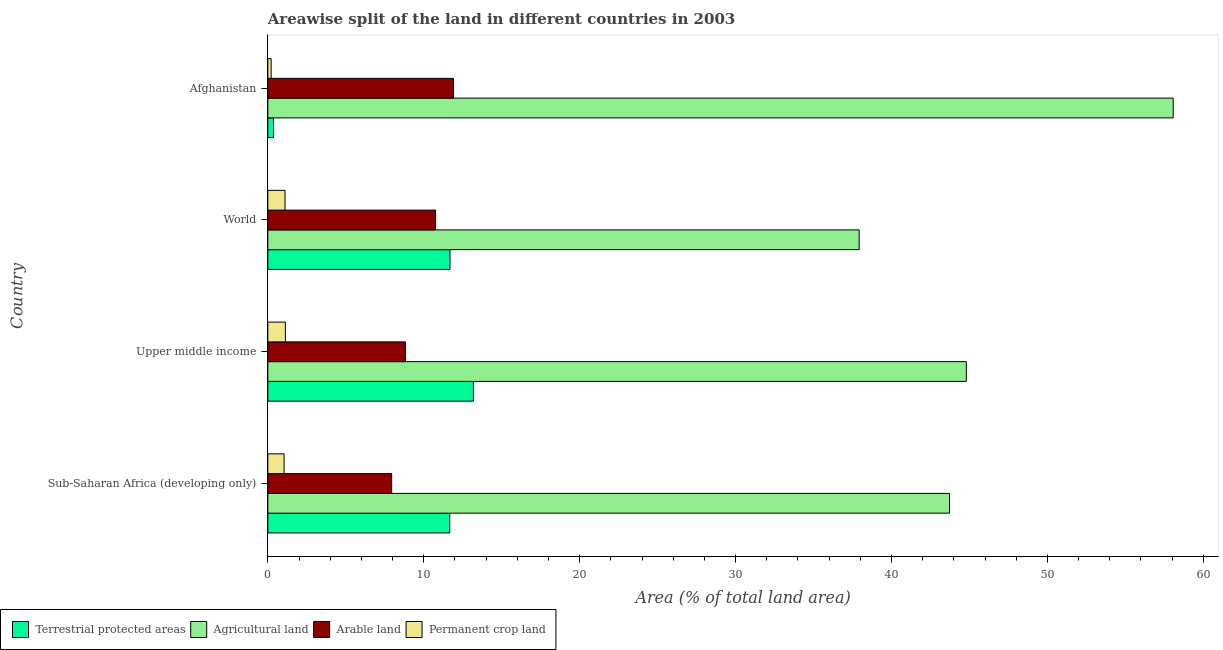Are the number of bars per tick equal to the number of legend labels?
Keep it short and to the point. Yes. Are the number of bars on each tick of the Y-axis equal?
Your response must be concise. Yes. How many bars are there on the 3rd tick from the top?
Your answer should be compact. 4. What is the label of the 1st group of bars from the top?
Offer a terse response. Afghanistan. In how many cases, is the number of bars for a given country not equal to the number of legend labels?
Make the answer very short. 0. What is the percentage of area under permanent crop land in Upper middle income?
Give a very brief answer. 1.13. Across all countries, what is the maximum percentage of area under arable land?
Offer a very short reply. 11.9. Across all countries, what is the minimum percentage of area under arable land?
Your answer should be very brief. 7.94. In which country was the percentage of area under agricultural land maximum?
Provide a succinct answer. Afghanistan. In which country was the percentage of area under permanent crop land minimum?
Ensure brevity in your answer.  Afghanistan. What is the total percentage of area under arable land in the graph?
Your answer should be compact. 39.43. What is the difference between the percentage of area under agricultural land in Upper middle income and that in World?
Keep it short and to the point. 6.87. What is the difference between the percentage of area under permanent crop land in World and the percentage of land under terrestrial protection in Upper middle income?
Your response must be concise. -12.08. What is the average percentage of land under terrestrial protection per country?
Make the answer very short. 9.22. What is the difference between the percentage of area under permanent crop land and percentage of area under arable land in Sub-Saharan Africa (developing only)?
Provide a short and direct response. -6.9. In how many countries, is the percentage of land under terrestrial protection greater than 48 %?
Make the answer very short. 0. What is the ratio of the percentage of area under arable land in Afghanistan to that in World?
Your answer should be very brief. 1.11. Is the difference between the percentage of area under agricultural land in Upper middle income and World greater than the difference between the percentage of area under arable land in Upper middle income and World?
Provide a succinct answer. Yes. What is the difference between the highest and the second highest percentage of area under permanent crop land?
Make the answer very short. 0.02. What is the difference between the highest and the lowest percentage of area under arable land?
Provide a succinct answer. 3.96. In how many countries, is the percentage of area under permanent crop land greater than the average percentage of area under permanent crop land taken over all countries?
Your response must be concise. 3. Is the sum of the percentage of area under permanent crop land in Afghanistan and World greater than the maximum percentage of area under agricultural land across all countries?
Ensure brevity in your answer.  No. What does the 3rd bar from the top in Upper middle income represents?
Give a very brief answer. Agricultural land. What does the 4th bar from the bottom in Sub-Saharan Africa (developing only) represents?
Keep it short and to the point. Permanent crop land. Are all the bars in the graph horizontal?
Your answer should be very brief. Yes. What is the difference between two consecutive major ticks on the X-axis?
Provide a succinct answer. 10. Where does the legend appear in the graph?
Give a very brief answer. Bottom left. How are the legend labels stacked?
Provide a short and direct response. Horizontal. What is the title of the graph?
Offer a very short reply. Areawise split of the land in different countries in 2003. Does "Other Minerals" appear as one of the legend labels in the graph?
Ensure brevity in your answer.  No. What is the label or title of the X-axis?
Your response must be concise. Area (% of total land area). What is the Area (% of total land area) in Terrestrial protected areas in Sub-Saharan Africa (developing only)?
Ensure brevity in your answer.  11.67. What is the Area (% of total land area) in Agricultural land in Sub-Saharan Africa (developing only)?
Your answer should be very brief. 43.72. What is the Area (% of total land area) in Arable land in Sub-Saharan Africa (developing only)?
Make the answer very short. 7.94. What is the Area (% of total land area) in Permanent crop land in Sub-Saharan Africa (developing only)?
Give a very brief answer. 1.04. What is the Area (% of total land area) in Terrestrial protected areas in Upper middle income?
Provide a short and direct response. 13.18. What is the Area (% of total land area) in Agricultural land in Upper middle income?
Ensure brevity in your answer.  44.8. What is the Area (% of total land area) in Arable land in Upper middle income?
Provide a succinct answer. 8.83. What is the Area (% of total land area) in Permanent crop land in Upper middle income?
Make the answer very short. 1.13. What is the Area (% of total land area) in Terrestrial protected areas in World?
Ensure brevity in your answer.  11.68. What is the Area (% of total land area) in Agricultural land in World?
Give a very brief answer. 37.93. What is the Area (% of total land area) of Arable land in World?
Keep it short and to the point. 10.76. What is the Area (% of total land area) in Permanent crop land in World?
Your answer should be very brief. 1.1. What is the Area (% of total land area) of Terrestrial protected areas in Afghanistan?
Keep it short and to the point. 0.37. What is the Area (% of total land area) in Agricultural land in Afghanistan?
Your answer should be very brief. 58.07. What is the Area (% of total land area) of Arable land in Afghanistan?
Provide a short and direct response. 11.9. What is the Area (% of total land area) in Permanent crop land in Afghanistan?
Your answer should be very brief. 0.21. Across all countries, what is the maximum Area (% of total land area) of Terrestrial protected areas?
Your response must be concise. 13.18. Across all countries, what is the maximum Area (% of total land area) of Agricultural land?
Make the answer very short. 58.07. Across all countries, what is the maximum Area (% of total land area) in Arable land?
Your answer should be very brief. 11.9. Across all countries, what is the maximum Area (% of total land area) in Permanent crop land?
Your answer should be compact. 1.13. Across all countries, what is the minimum Area (% of total land area) in Terrestrial protected areas?
Your answer should be compact. 0.37. Across all countries, what is the minimum Area (% of total land area) of Agricultural land?
Ensure brevity in your answer.  37.93. Across all countries, what is the minimum Area (% of total land area) in Arable land?
Make the answer very short. 7.94. Across all countries, what is the minimum Area (% of total land area) in Permanent crop land?
Your answer should be compact. 0.21. What is the total Area (% of total land area) in Terrestrial protected areas in the graph?
Ensure brevity in your answer.  36.9. What is the total Area (% of total land area) in Agricultural land in the graph?
Provide a short and direct response. 184.51. What is the total Area (% of total land area) in Arable land in the graph?
Ensure brevity in your answer.  39.43. What is the total Area (% of total land area) in Permanent crop land in the graph?
Provide a succinct answer. 3.48. What is the difference between the Area (% of total land area) of Terrestrial protected areas in Sub-Saharan Africa (developing only) and that in Upper middle income?
Your answer should be compact. -1.52. What is the difference between the Area (% of total land area) in Agricultural land in Sub-Saharan Africa (developing only) and that in Upper middle income?
Your response must be concise. -1.08. What is the difference between the Area (% of total land area) of Arable land in Sub-Saharan Africa (developing only) and that in Upper middle income?
Your response must be concise. -0.89. What is the difference between the Area (% of total land area) of Permanent crop land in Sub-Saharan Africa (developing only) and that in Upper middle income?
Your answer should be very brief. -0.08. What is the difference between the Area (% of total land area) in Terrestrial protected areas in Sub-Saharan Africa (developing only) and that in World?
Offer a very short reply. -0.02. What is the difference between the Area (% of total land area) in Agricultural land in Sub-Saharan Africa (developing only) and that in World?
Provide a short and direct response. 5.8. What is the difference between the Area (% of total land area) in Arable land in Sub-Saharan Africa (developing only) and that in World?
Offer a very short reply. -2.82. What is the difference between the Area (% of total land area) in Permanent crop land in Sub-Saharan Africa (developing only) and that in World?
Offer a terse response. -0.06. What is the difference between the Area (% of total land area) of Terrestrial protected areas in Sub-Saharan Africa (developing only) and that in Afghanistan?
Your answer should be very brief. 11.3. What is the difference between the Area (% of total land area) in Agricultural land in Sub-Saharan Africa (developing only) and that in Afghanistan?
Offer a very short reply. -14.35. What is the difference between the Area (% of total land area) in Arable land in Sub-Saharan Africa (developing only) and that in Afghanistan?
Your response must be concise. -3.96. What is the difference between the Area (% of total land area) of Permanent crop land in Sub-Saharan Africa (developing only) and that in Afghanistan?
Keep it short and to the point. 0.83. What is the difference between the Area (% of total land area) in Terrestrial protected areas in Upper middle income and that in World?
Your response must be concise. 1.5. What is the difference between the Area (% of total land area) of Agricultural land in Upper middle income and that in World?
Your answer should be compact. 6.87. What is the difference between the Area (% of total land area) in Arable land in Upper middle income and that in World?
Your response must be concise. -1.93. What is the difference between the Area (% of total land area) of Permanent crop land in Upper middle income and that in World?
Your answer should be very brief. 0.02. What is the difference between the Area (% of total land area) in Terrestrial protected areas in Upper middle income and that in Afghanistan?
Give a very brief answer. 12.82. What is the difference between the Area (% of total land area) in Agricultural land in Upper middle income and that in Afghanistan?
Your answer should be compact. -13.27. What is the difference between the Area (% of total land area) of Arable land in Upper middle income and that in Afghanistan?
Offer a very short reply. -3.08. What is the difference between the Area (% of total land area) of Permanent crop land in Upper middle income and that in Afghanistan?
Make the answer very short. 0.91. What is the difference between the Area (% of total land area) in Terrestrial protected areas in World and that in Afghanistan?
Provide a succinct answer. 11.32. What is the difference between the Area (% of total land area) in Agricultural land in World and that in Afghanistan?
Make the answer very short. -20.14. What is the difference between the Area (% of total land area) in Arable land in World and that in Afghanistan?
Provide a short and direct response. -1.15. What is the difference between the Area (% of total land area) in Permanent crop land in World and that in Afghanistan?
Your answer should be compact. 0.89. What is the difference between the Area (% of total land area) in Terrestrial protected areas in Sub-Saharan Africa (developing only) and the Area (% of total land area) in Agricultural land in Upper middle income?
Your response must be concise. -33.13. What is the difference between the Area (% of total land area) in Terrestrial protected areas in Sub-Saharan Africa (developing only) and the Area (% of total land area) in Arable land in Upper middle income?
Your response must be concise. 2.84. What is the difference between the Area (% of total land area) in Terrestrial protected areas in Sub-Saharan Africa (developing only) and the Area (% of total land area) in Permanent crop land in Upper middle income?
Your response must be concise. 10.54. What is the difference between the Area (% of total land area) of Agricultural land in Sub-Saharan Africa (developing only) and the Area (% of total land area) of Arable land in Upper middle income?
Offer a terse response. 34.89. What is the difference between the Area (% of total land area) in Agricultural land in Sub-Saharan Africa (developing only) and the Area (% of total land area) in Permanent crop land in Upper middle income?
Your response must be concise. 42.6. What is the difference between the Area (% of total land area) in Arable land in Sub-Saharan Africa (developing only) and the Area (% of total land area) in Permanent crop land in Upper middle income?
Provide a short and direct response. 6.81. What is the difference between the Area (% of total land area) in Terrestrial protected areas in Sub-Saharan Africa (developing only) and the Area (% of total land area) in Agricultural land in World?
Ensure brevity in your answer.  -26.26. What is the difference between the Area (% of total land area) of Terrestrial protected areas in Sub-Saharan Africa (developing only) and the Area (% of total land area) of Arable land in World?
Your response must be concise. 0.91. What is the difference between the Area (% of total land area) of Terrestrial protected areas in Sub-Saharan Africa (developing only) and the Area (% of total land area) of Permanent crop land in World?
Your answer should be very brief. 10.56. What is the difference between the Area (% of total land area) of Agricultural land in Sub-Saharan Africa (developing only) and the Area (% of total land area) of Arable land in World?
Offer a terse response. 32.97. What is the difference between the Area (% of total land area) in Agricultural land in Sub-Saharan Africa (developing only) and the Area (% of total land area) in Permanent crop land in World?
Your response must be concise. 42.62. What is the difference between the Area (% of total land area) in Arable land in Sub-Saharan Africa (developing only) and the Area (% of total land area) in Permanent crop land in World?
Your answer should be very brief. 6.84. What is the difference between the Area (% of total land area) of Terrestrial protected areas in Sub-Saharan Africa (developing only) and the Area (% of total land area) of Agricultural land in Afghanistan?
Your response must be concise. -46.4. What is the difference between the Area (% of total land area) in Terrestrial protected areas in Sub-Saharan Africa (developing only) and the Area (% of total land area) in Arable land in Afghanistan?
Offer a terse response. -0.24. What is the difference between the Area (% of total land area) in Terrestrial protected areas in Sub-Saharan Africa (developing only) and the Area (% of total land area) in Permanent crop land in Afghanistan?
Ensure brevity in your answer.  11.46. What is the difference between the Area (% of total land area) of Agricultural land in Sub-Saharan Africa (developing only) and the Area (% of total land area) of Arable land in Afghanistan?
Provide a short and direct response. 31.82. What is the difference between the Area (% of total land area) of Agricultural land in Sub-Saharan Africa (developing only) and the Area (% of total land area) of Permanent crop land in Afghanistan?
Your response must be concise. 43.51. What is the difference between the Area (% of total land area) of Arable land in Sub-Saharan Africa (developing only) and the Area (% of total land area) of Permanent crop land in Afghanistan?
Provide a short and direct response. 7.73. What is the difference between the Area (% of total land area) in Terrestrial protected areas in Upper middle income and the Area (% of total land area) in Agricultural land in World?
Provide a short and direct response. -24.74. What is the difference between the Area (% of total land area) of Terrestrial protected areas in Upper middle income and the Area (% of total land area) of Arable land in World?
Give a very brief answer. 2.43. What is the difference between the Area (% of total land area) of Terrestrial protected areas in Upper middle income and the Area (% of total land area) of Permanent crop land in World?
Provide a short and direct response. 12.08. What is the difference between the Area (% of total land area) of Agricultural land in Upper middle income and the Area (% of total land area) of Arable land in World?
Your answer should be compact. 34.04. What is the difference between the Area (% of total land area) of Agricultural land in Upper middle income and the Area (% of total land area) of Permanent crop land in World?
Your answer should be very brief. 43.69. What is the difference between the Area (% of total land area) in Arable land in Upper middle income and the Area (% of total land area) in Permanent crop land in World?
Provide a short and direct response. 7.73. What is the difference between the Area (% of total land area) of Terrestrial protected areas in Upper middle income and the Area (% of total land area) of Agricultural land in Afghanistan?
Your answer should be compact. -44.88. What is the difference between the Area (% of total land area) in Terrestrial protected areas in Upper middle income and the Area (% of total land area) in Arable land in Afghanistan?
Offer a very short reply. 1.28. What is the difference between the Area (% of total land area) of Terrestrial protected areas in Upper middle income and the Area (% of total land area) of Permanent crop land in Afghanistan?
Your answer should be very brief. 12.97. What is the difference between the Area (% of total land area) in Agricultural land in Upper middle income and the Area (% of total land area) in Arable land in Afghanistan?
Your answer should be very brief. 32.89. What is the difference between the Area (% of total land area) in Agricultural land in Upper middle income and the Area (% of total land area) in Permanent crop land in Afghanistan?
Offer a very short reply. 44.59. What is the difference between the Area (% of total land area) of Arable land in Upper middle income and the Area (% of total land area) of Permanent crop land in Afghanistan?
Give a very brief answer. 8.62. What is the difference between the Area (% of total land area) in Terrestrial protected areas in World and the Area (% of total land area) in Agricultural land in Afghanistan?
Ensure brevity in your answer.  -46.38. What is the difference between the Area (% of total land area) in Terrestrial protected areas in World and the Area (% of total land area) in Arable land in Afghanistan?
Offer a very short reply. -0.22. What is the difference between the Area (% of total land area) of Terrestrial protected areas in World and the Area (% of total land area) of Permanent crop land in Afghanistan?
Your answer should be very brief. 11.47. What is the difference between the Area (% of total land area) of Agricultural land in World and the Area (% of total land area) of Arable land in Afghanistan?
Your answer should be very brief. 26.02. What is the difference between the Area (% of total land area) in Agricultural land in World and the Area (% of total land area) in Permanent crop land in Afghanistan?
Offer a terse response. 37.71. What is the difference between the Area (% of total land area) of Arable land in World and the Area (% of total land area) of Permanent crop land in Afghanistan?
Give a very brief answer. 10.54. What is the average Area (% of total land area) of Terrestrial protected areas per country?
Provide a short and direct response. 9.23. What is the average Area (% of total land area) in Agricultural land per country?
Offer a terse response. 46.13. What is the average Area (% of total land area) in Arable land per country?
Ensure brevity in your answer.  9.86. What is the average Area (% of total land area) of Permanent crop land per country?
Offer a terse response. 0.87. What is the difference between the Area (% of total land area) in Terrestrial protected areas and Area (% of total land area) in Agricultural land in Sub-Saharan Africa (developing only)?
Offer a very short reply. -32.05. What is the difference between the Area (% of total land area) in Terrestrial protected areas and Area (% of total land area) in Arable land in Sub-Saharan Africa (developing only)?
Give a very brief answer. 3.73. What is the difference between the Area (% of total land area) of Terrestrial protected areas and Area (% of total land area) of Permanent crop land in Sub-Saharan Africa (developing only)?
Provide a succinct answer. 10.63. What is the difference between the Area (% of total land area) in Agricultural land and Area (% of total land area) in Arable land in Sub-Saharan Africa (developing only)?
Your answer should be compact. 35.78. What is the difference between the Area (% of total land area) in Agricultural land and Area (% of total land area) in Permanent crop land in Sub-Saharan Africa (developing only)?
Offer a very short reply. 42.68. What is the difference between the Area (% of total land area) of Arable land and Area (% of total land area) of Permanent crop land in Sub-Saharan Africa (developing only)?
Give a very brief answer. 6.9. What is the difference between the Area (% of total land area) in Terrestrial protected areas and Area (% of total land area) in Agricultural land in Upper middle income?
Offer a terse response. -31.61. What is the difference between the Area (% of total land area) in Terrestrial protected areas and Area (% of total land area) in Arable land in Upper middle income?
Give a very brief answer. 4.36. What is the difference between the Area (% of total land area) of Terrestrial protected areas and Area (% of total land area) of Permanent crop land in Upper middle income?
Make the answer very short. 12.06. What is the difference between the Area (% of total land area) of Agricultural land and Area (% of total land area) of Arable land in Upper middle income?
Provide a short and direct response. 35.97. What is the difference between the Area (% of total land area) of Agricultural land and Area (% of total land area) of Permanent crop land in Upper middle income?
Your answer should be compact. 43.67. What is the difference between the Area (% of total land area) in Arable land and Area (% of total land area) in Permanent crop land in Upper middle income?
Ensure brevity in your answer.  7.7. What is the difference between the Area (% of total land area) in Terrestrial protected areas and Area (% of total land area) in Agricultural land in World?
Your answer should be very brief. -26.24. What is the difference between the Area (% of total land area) in Terrestrial protected areas and Area (% of total land area) in Arable land in World?
Offer a very short reply. 0.93. What is the difference between the Area (% of total land area) of Terrestrial protected areas and Area (% of total land area) of Permanent crop land in World?
Provide a succinct answer. 10.58. What is the difference between the Area (% of total land area) in Agricultural land and Area (% of total land area) in Arable land in World?
Keep it short and to the point. 27.17. What is the difference between the Area (% of total land area) in Agricultural land and Area (% of total land area) in Permanent crop land in World?
Offer a terse response. 36.82. What is the difference between the Area (% of total land area) of Arable land and Area (% of total land area) of Permanent crop land in World?
Offer a terse response. 9.65. What is the difference between the Area (% of total land area) in Terrestrial protected areas and Area (% of total land area) in Agricultural land in Afghanistan?
Your answer should be compact. -57.7. What is the difference between the Area (% of total land area) of Terrestrial protected areas and Area (% of total land area) of Arable land in Afghanistan?
Your answer should be very brief. -11.54. What is the difference between the Area (% of total land area) of Terrestrial protected areas and Area (% of total land area) of Permanent crop land in Afghanistan?
Your response must be concise. 0.16. What is the difference between the Area (% of total land area) of Agricultural land and Area (% of total land area) of Arable land in Afghanistan?
Give a very brief answer. 46.16. What is the difference between the Area (% of total land area) of Agricultural land and Area (% of total land area) of Permanent crop land in Afghanistan?
Keep it short and to the point. 57.86. What is the difference between the Area (% of total land area) of Arable land and Area (% of total land area) of Permanent crop land in Afghanistan?
Give a very brief answer. 11.69. What is the ratio of the Area (% of total land area) in Terrestrial protected areas in Sub-Saharan Africa (developing only) to that in Upper middle income?
Your answer should be very brief. 0.88. What is the ratio of the Area (% of total land area) in Agricultural land in Sub-Saharan Africa (developing only) to that in Upper middle income?
Keep it short and to the point. 0.98. What is the ratio of the Area (% of total land area) of Arable land in Sub-Saharan Africa (developing only) to that in Upper middle income?
Ensure brevity in your answer.  0.9. What is the ratio of the Area (% of total land area) in Permanent crop land in Sub-Saharan Africa (developing only) to that in Upper middle income?
Offer a terse response. 0.93. What is the ratio of the Area (% of total land area) of Terrestrial protected areas in Sub-Saharan Africa (developing only) to that in World?
Keep it short and to the point. 1. What is the ratio of the Area (% of total land area) of Agricultural land in Sub-Saharan Africa (developing only) to that in World?
Make the answer very short. 1.15. What is the ratio of the Area (% of total land area) of Arable land in Sub-Saharan Africa (developing only) to that in World?
Provide a short and direct response. 0.74. What is the ratio of the Area (% of total land area) in Permanent crop land in Sub-Saharan Africa (developing only) to that in World?
Give a very brief answer. 0.94. What is the ratio of the Area (% of total land area) of Terrestrial protected areas in Sub-Saharan Africa (developing only) to that in Afghanistan?
Offer a very short reply. 31.8. What is the ratio of the Area (% of total land area) of Agricultural land in Sub-Saharan Africa (developing only) to that in Afghanistan?
Offer a very short reply. 0.75. What is the ratio of the Area (% of total land area) of Arable land in Sub-Saharan Africa (developing only) to that in Afghanistan?
Ensure brevity in your answer.  0.67. What is the ratio of the Area (% of total land area) of Permanent crop land in Sub-Saharan Africa (developing only) to that in Afghanistan?
Keep it short and to the point. 4.93. What is the ratio of the Area (% of total land area) in Terrestrial protected areas in Upper middle income to that in World?
Make the answer very short. 1.13. What is the ratio of the Area (% of total land area) of Agricultural land in Upper middle income to that in World?
Keep it short and to the point. 1.18. What is the ratio of the Area (% of total land area) in Arable land in Upper middle income to that in World?
Keep it short and to the point. 0.82. What is the ratio of the Area (% of total land area) in Permanent crop land in Upper middle income to that in World?
Offer a very short reply. 1.02. What is the ratio of the Area (% of total land area) in Terrestrial protected areas in Upper middle income to that in Afghanistan?
Your answer should be very brief. 35.94. What is the ratio of the Area (% of total land area) in Agricultural land in Upper middle income to that in Afghanistan?
Provide a short and direct response. 0.77. What is the ratio of the Area (% of total land area) of Arable land in Upper middle income to that in Afghanistan?
Ensure brevity in your answer.  0.74. What is the ratio of the Area (% of total land area) in Permanent crop land in Upper middle income to that in Afghanistan?
Ensure brevity in your answer.  5.32. What is the ratio of the Area (% of total land area) of Terrestrial protected areas in World to that in Afghanistan?
Keep it short and to the point. 31.84. What is the ratio of the Area (% of total land area) of Agricultural land in World to that in Afghanistan?
Keep it short and to the point. 0.65. What is the ratio of the Area (% of total land area) in Arable land in World to that in Afghanistan?
Your answer should be compact. 0.9. What is the ratio of the Area (% of total land area) of Permanent crop land in World to that in Afghanistan?
Provide a succinct answer. 5.22. What is the difference between the highest and the second highest Area (% of total land area) of Terrestrial protected areas?
Provide a short and direct response. 1.5. What is the difference between the highest and the second highest Area (% of total land area) in Agricultural land?
Provide a short and direct response. 13.27. What is the difference between the highest and the second highest Area (% of total land area) of Arable land?
Offer a terse response. 1.15. What is the difference between the highest and the second highest Area (% of total land area) of Permanent crop land?
Make the answer very short. 0.02. What is the difference between the highest and the lowest Area (% of total land area) of Terrestrial protected areas?
Provide a short and direct response. 12.82. What is the difference between the highest and the lowest Area (% of total land area) in Agricultural land?
Offer a terse response. 20.14. What is the difference between the highest and the lowest Area (% of total land area) in Arable land?
Offer a terse response. 3.96. What is the difference between the highest and the lowest Area (% of total land area) of Permanent crop land?
Your answer should be compact. 0.91. 